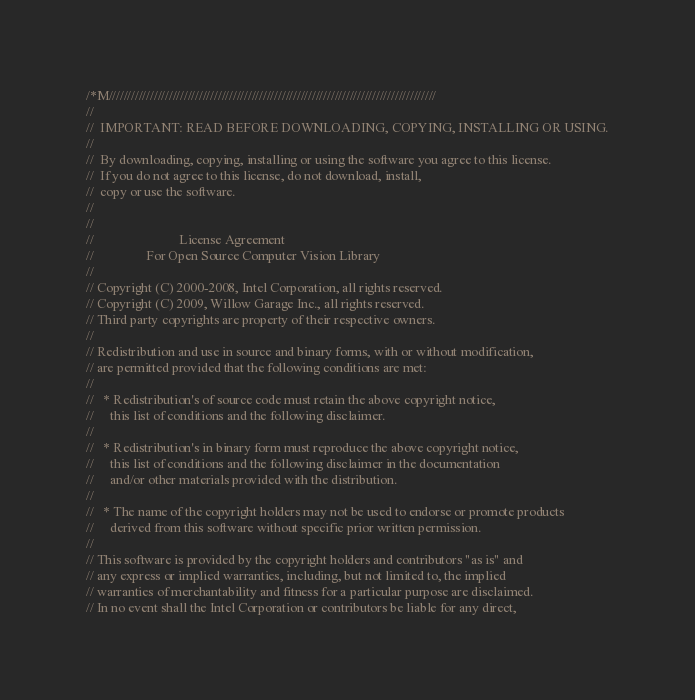<code> <loc_0><loc_0><loc_500><loc_500><_C++_>/*M///////////////////////////////////////////////////////////////////////////////////////
//
//  IMPORTANT: READ BEFORE DOWNLOADING, COPYING, INSTALLING OR USING.
//
//  By downloading, copying, installing or using the software you agree to this license.
//  If you do not agree to this license, do not download, install,
//  copy or use the software.
//
//
//                          License Agreement
//                For Open Source Computer Vision Library
//
// Copyright (C) 2000-2008, Intel Corporation, all rights reserved.
// Copyright (C) 2009, Willow Garage Inc., all rights reserved.
// Third party copyrights are property of their respective owners.
//
// Redistribution and use in source and binary forms, with or without modification,
// are permitted provided that the following conditions are met:
//
//   * Redistribution's of source code must retain the above copyright notice,
//     this list of conditions and the following disclaimer.
//
//   * Redistribution's in binary form must reproduce the above copyright notice,
//     this list of conditions and the following disclaimer in the documentation
//     and/or other materials provided with the distribution.
//
//   * The name of the copyright holders may not be used to endorse or promote products
//     derived from this software without specific prior written permission.
//
// This software is provided by the copyright holders and contributors "as is" and
// any express or implied warranties, including, but not limited to, the implied
// warranties of merchantability and fitness for a particular purpose are disclaimed.
// In no event shall the Intel Corporation or contributors be liable for any direct,</code> 